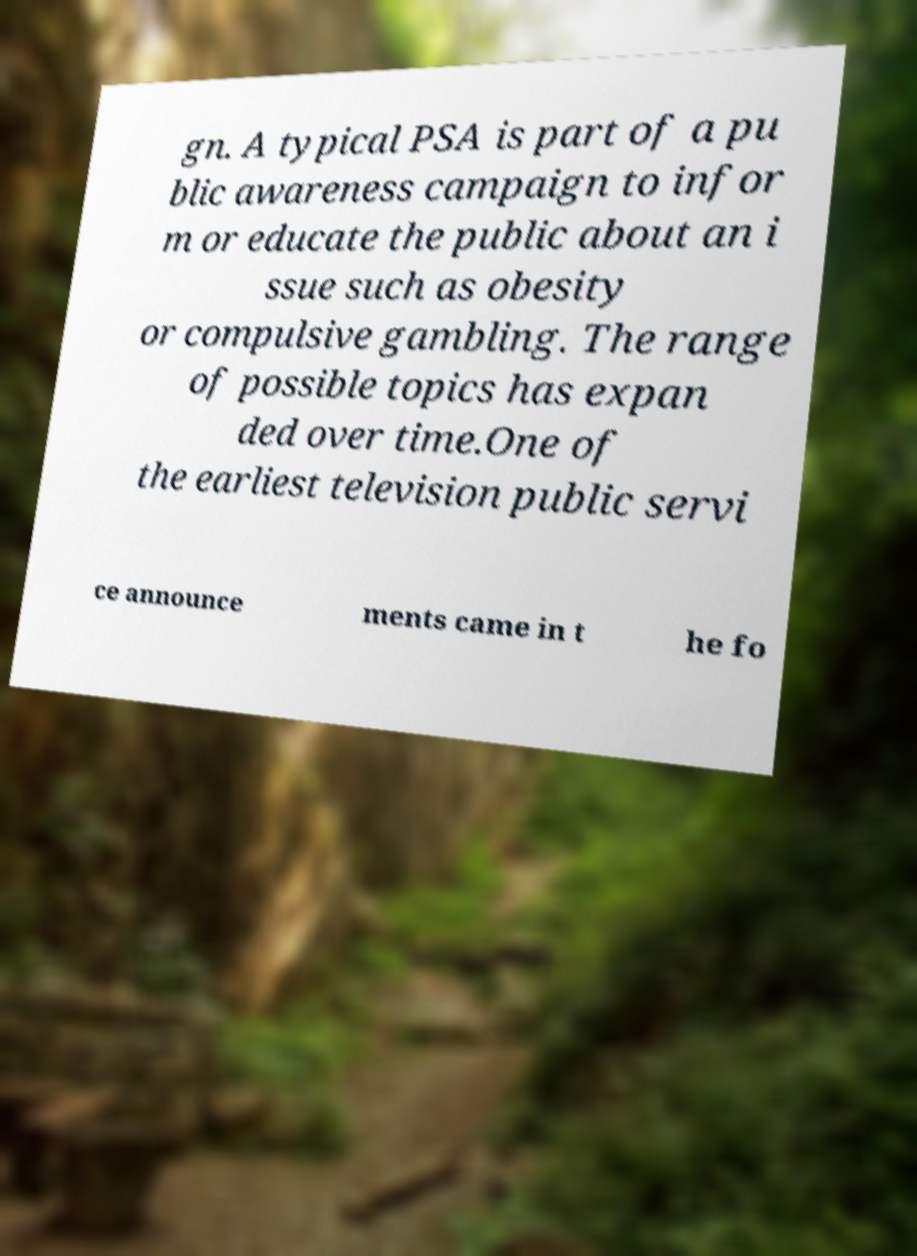Please read and relay the text visible in this image. What does it say? gn. A typical PSA is part of a pu blic awareness campaign to infor m or educate the public about an i ssue such as obesity or compulsive gambling. The range of possible topics has expan ded over time.One of the earliest television public servi ce announce ments came in t he fo 